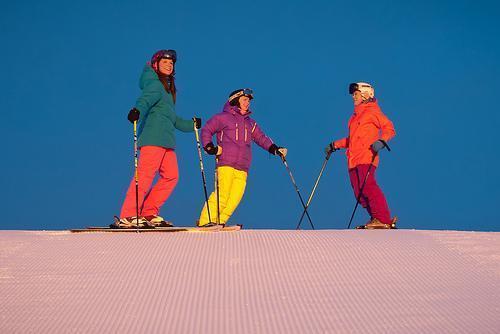How many people are there?
Give a very brief answer. 3. How many skiers are pictured?
Give a very brief answer. 3. 